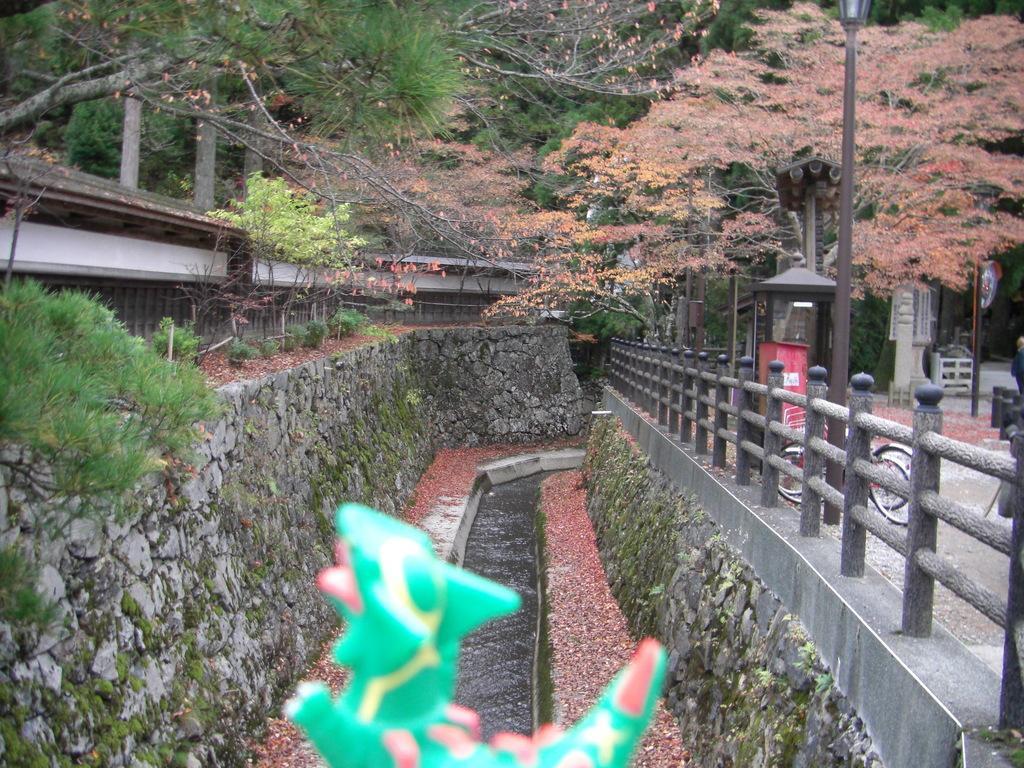How would you summarize this image in a sentence or two? In this image, we can see a bridge, bicycle, poles, stands, trees and sheds and in the front, we can see a toy. At the bottom, there is pond. 